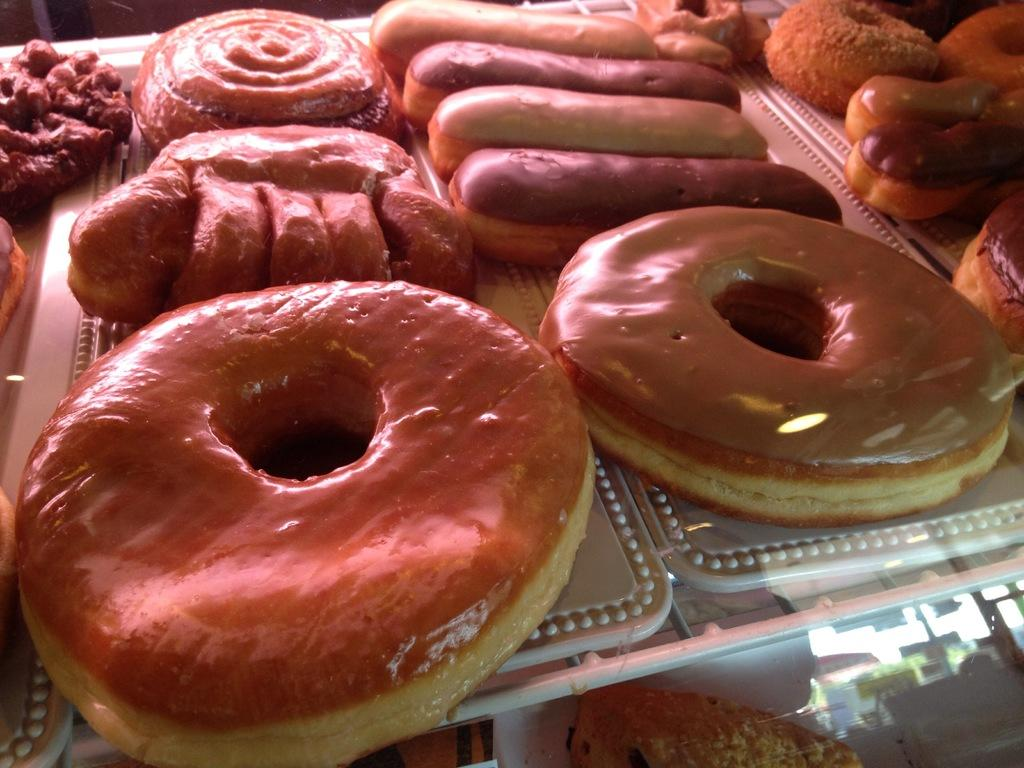What is present in the image? There is a table in the image. What can be found on the table? There are food items on the table. How many cows are visible in the image? There are no cows present in the image; it only features a table with food items. 